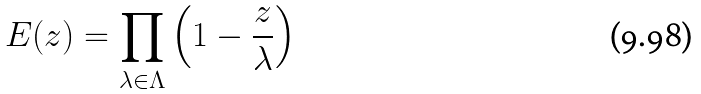<formula> <loc_0><loc_0><loc_500><loc_500>E ( z ) = \prod _ { \lambda \in \Lambda } \left ( 1 - \frac { z } { \lambda } \right )</formula> 